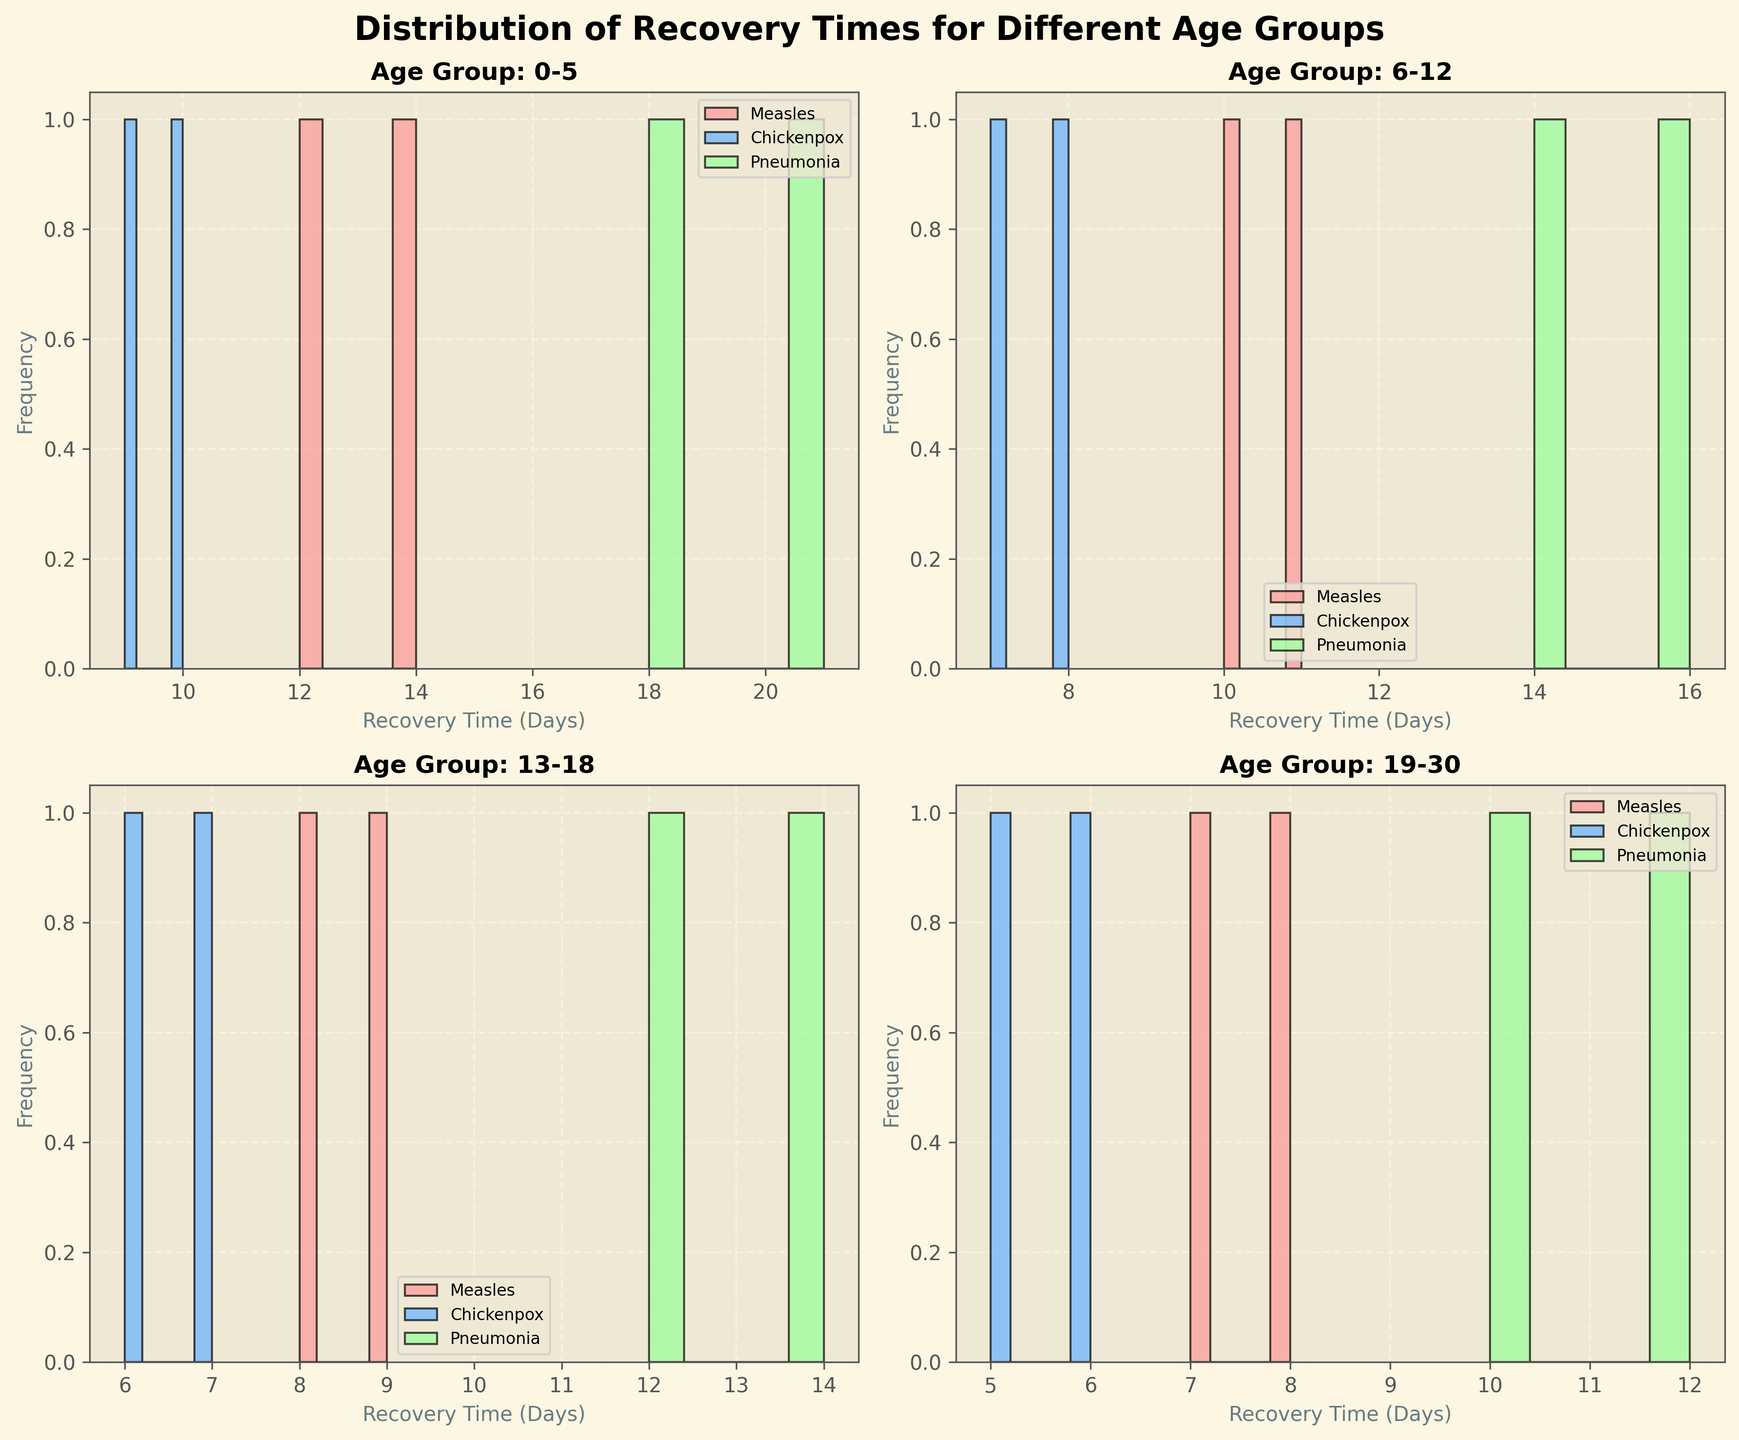How many histograms are displayed on the entire figure? The figure consists of 4 subplots, each representing a different age group.
Answer: 4 Which disease has the shortest recovery time in the 13-18 age group? By analyzing the histogram for the 13-18 age group, chickenpox's shortest recovery time is seen at 6 days.
Answer: Chickenpox What are the recovery times for Measles in the 0-5 age group? The histogram for the 0-5 age group shows recovery times for Measles concentrated around 12 and 14 days.
Answer: 12 and 14 days Which age group has the longest recovery time for Pneumonia? Looking at the histograms, the 0-5 age group shows the longest recovery times for Pneumonia, peaking at 18 and 21 days.
Answer: 0-5 Compare the average recovery times for Chickenpox between the 6-12 and 19-30 age groups. The histograms show recovery times of Chickenpox for 6-12 as 7 and 8 days, and for 19-30 as 5 and 6 days. The averages are (7+8)/2 = 7.5 days and (5+6)/2 = 5.5 days respectively. Therefore, 6-12 age group has a higher average recovery time.
Answer: 6-12 > 19-30 What's the title of the figure and of the subplots? The main title of the figure is "Distribution of Recovery Times for Different Age Groups." Each subplot title starts with "Age Group:" followed by the specific age group, such as "0-5," "6-12," etc.
Answer: Distribution of Recovery Times for Different Age Groups; Age Group: 0-5, Age Group: 6-12, Age Group: 13-18, Age Group: 19-30 Which age group has the shortest recovery time overall, and for which disease? Analyzing the histograms, the 19-30 age group shows the shortest recovery time overall, which is 5 days for Chickenpox.
Answer: 19-30, Chickenpox Which disease shows the least variation in recovery times across all age groups? By reviewing the histograms, Chickenpox's recovery times across all age groups seem clustered in narrow intervals compared to the other diseases.
Answer: Chickenpox 